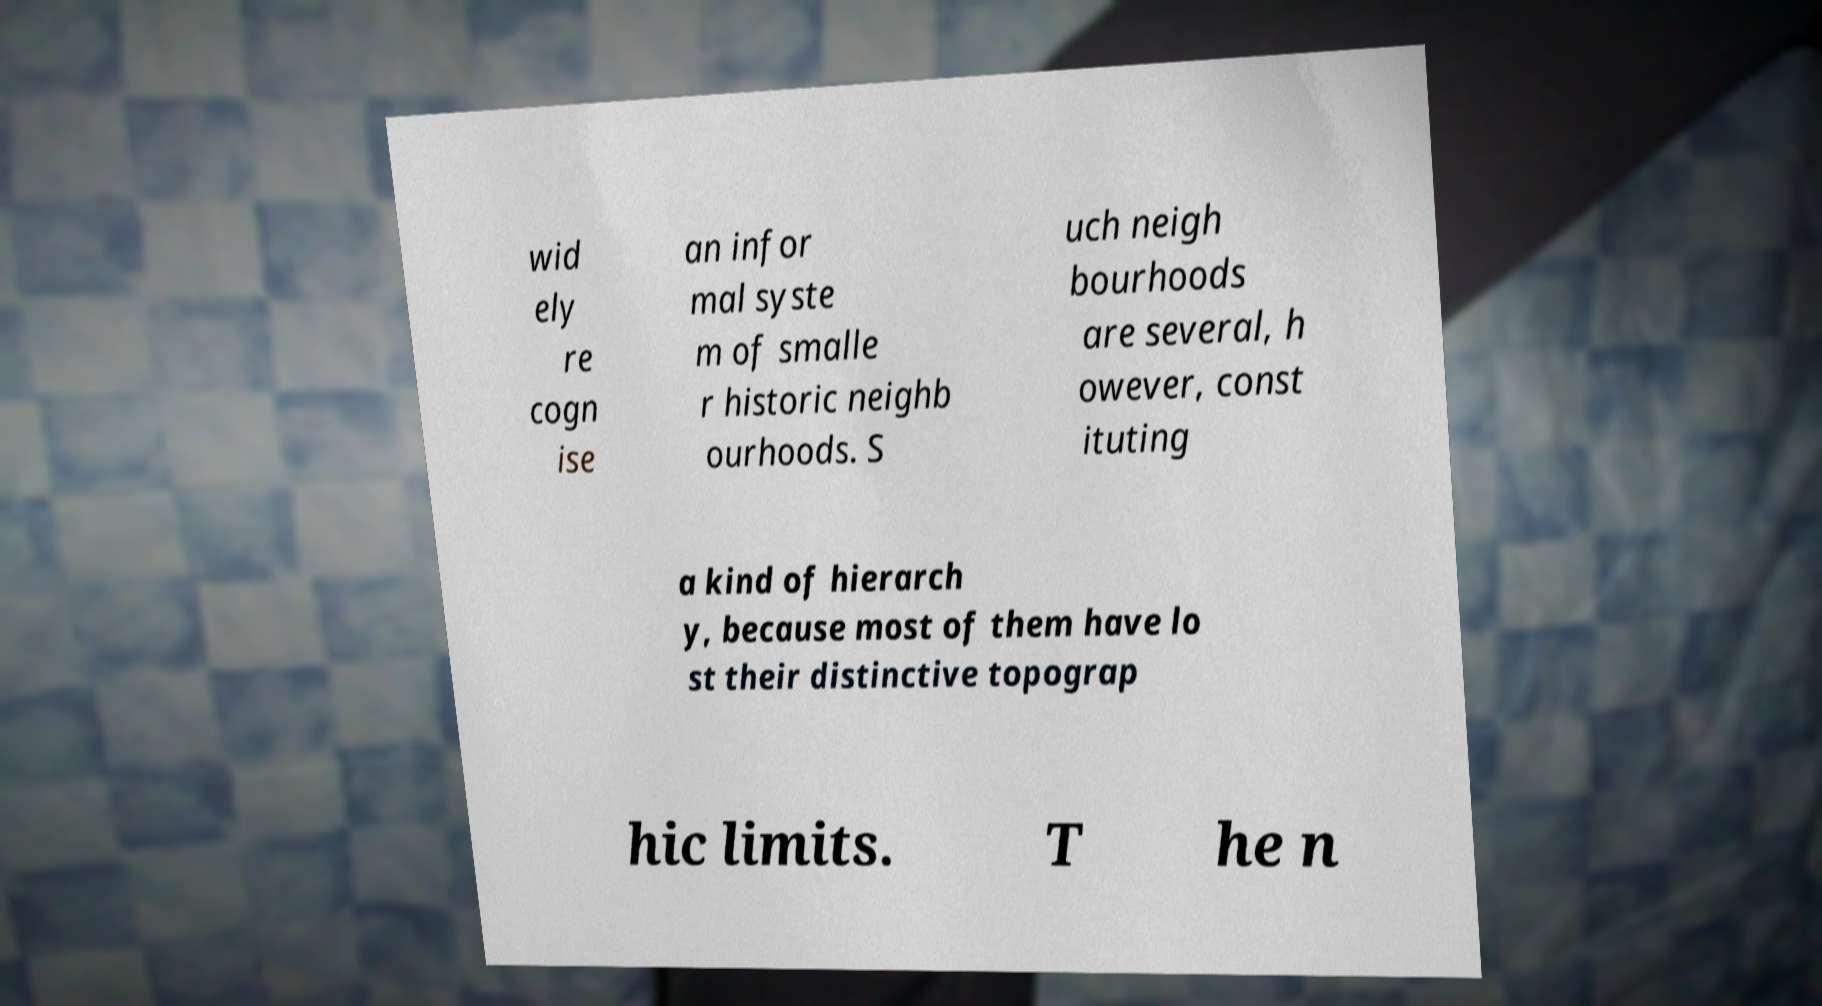Can you accurately transcribe the text from the provided image for me? wid ely re cogn ise an infor mal syste m of smalle r historic neighb ourhoods. S uch neigh bourhoods are several, h owever, const ituting a kind of hierarch y, because most of them have lo st their distinctive topograp hic limits. T he n 